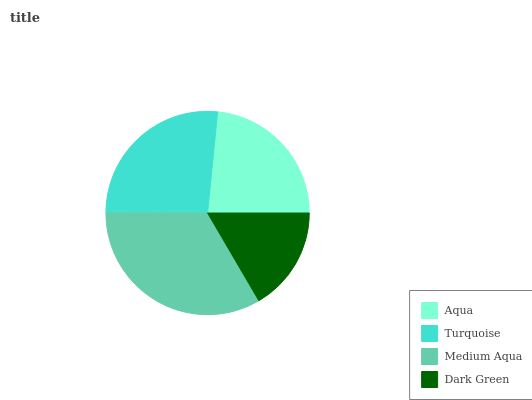Is Dark Green the minimum?
Answer yes or no. Yes. Is Medium Aqua the maximum?
Answer yes or no. Yes. Is Turquoise the minimum?
Answer yes or no. No. Is Turquoise the maximum?
Answer yes or no. No. Is Turquoise greater than Aqua?
Answer yes or no. Yes. Is Aqua less than Turquoise?
Answer yes or no. Yes. Is Aqua greater than Turquoise?
Answer yes or no. No. Is Turquoise less than Aqua?
Answer yes or no. No. Is Turquoise the high median?
Answer yes or no. Yes. Is Aqua the low median?
Answer yes or no. Yes. Is Medium Aqua the high median?
Answer yes or no. No. Is Dark Green the low median?
Answer yes or no. No. 